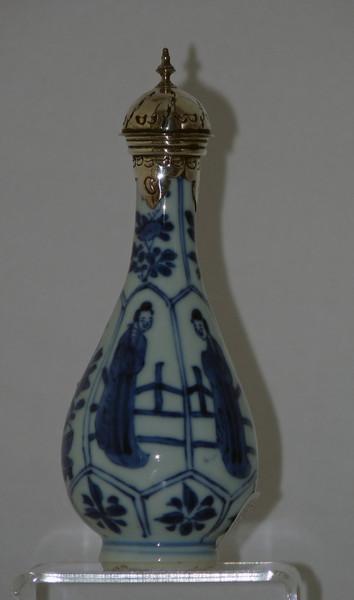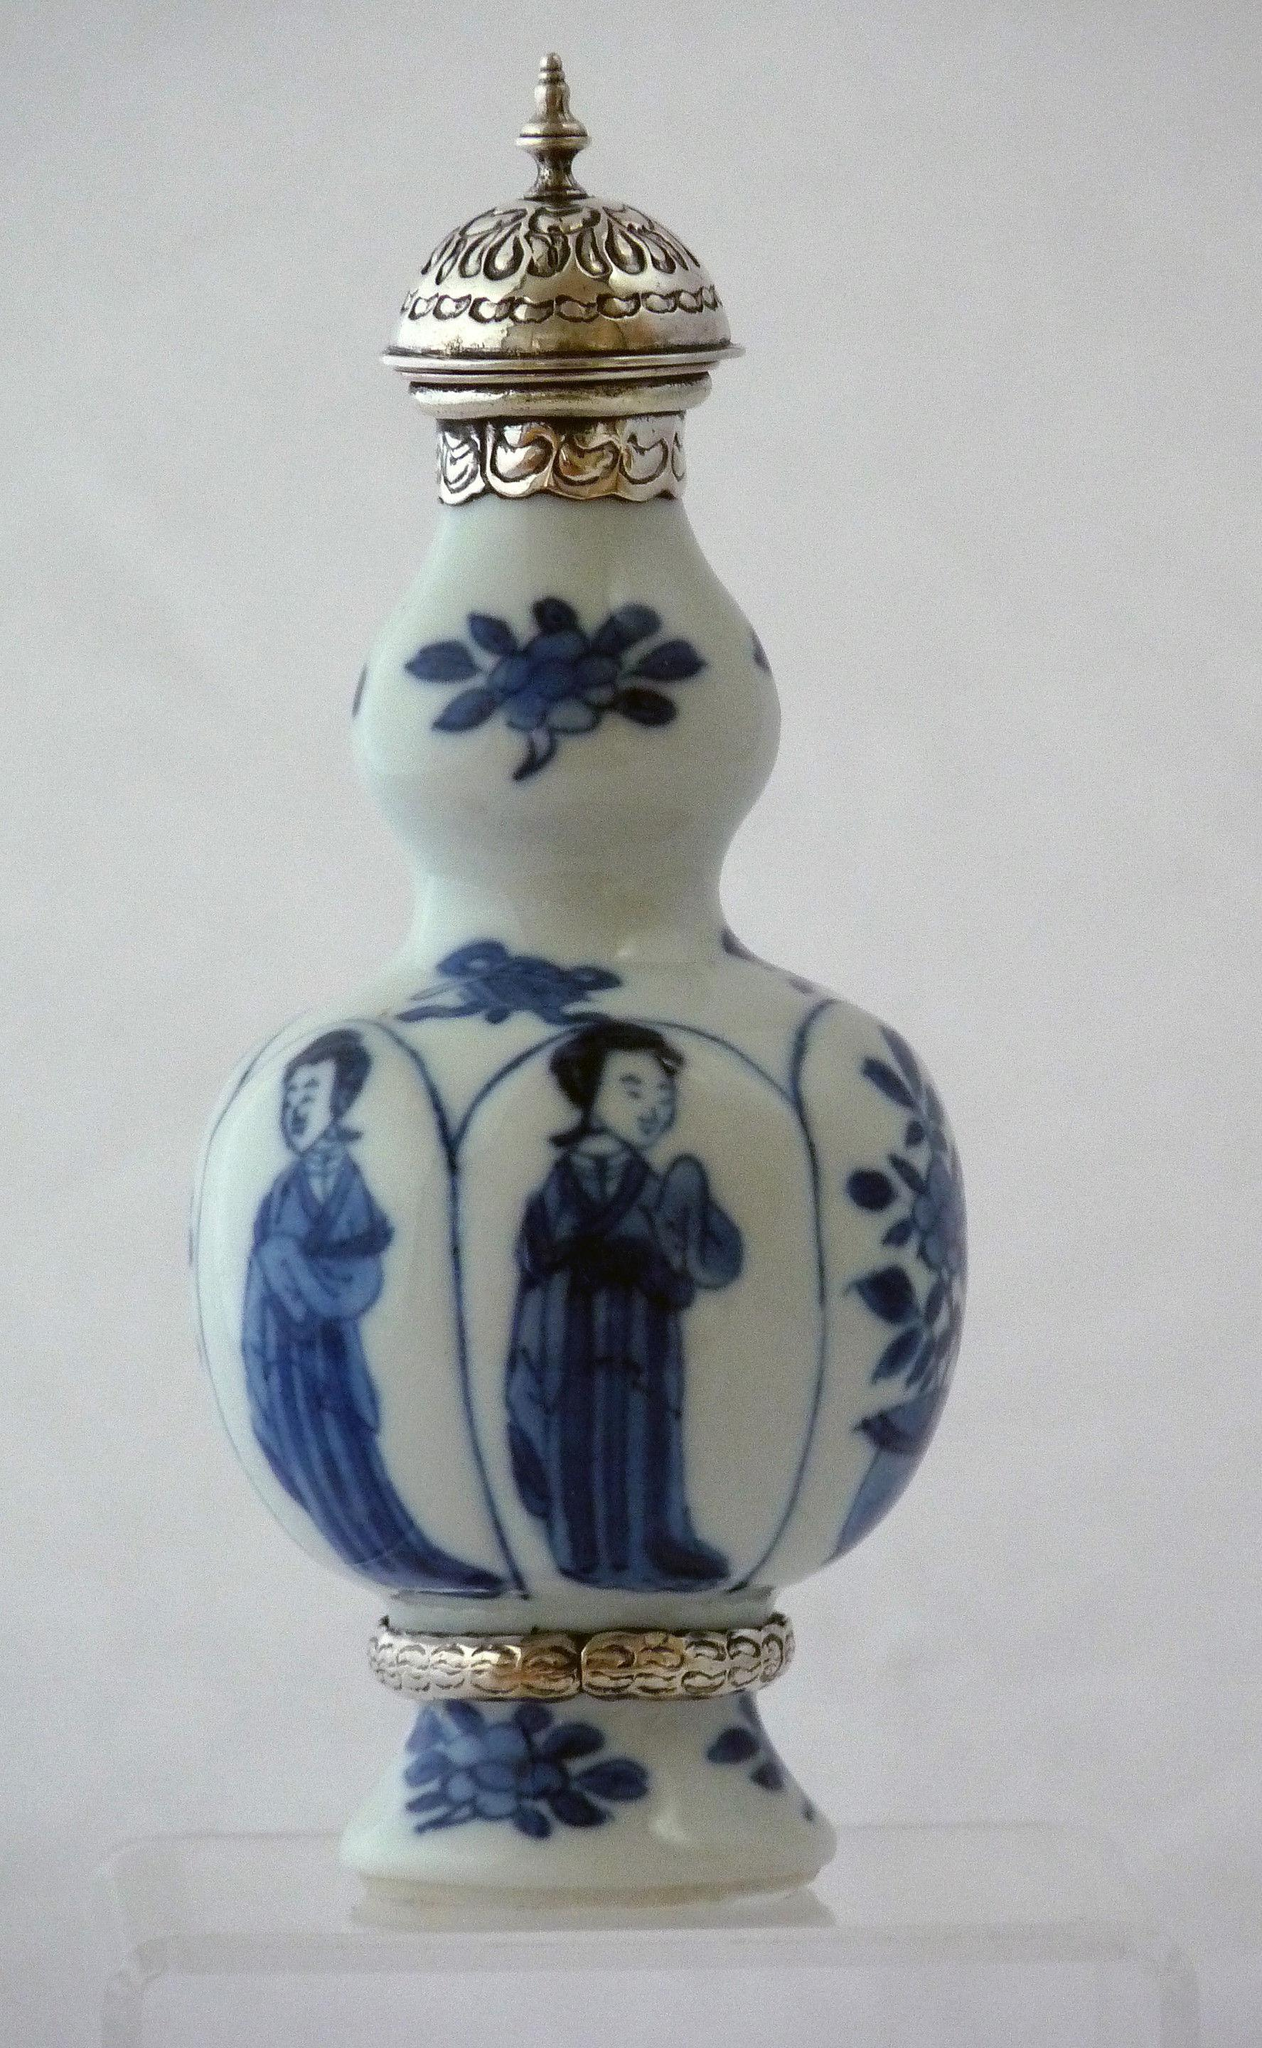The first image is the image on the left, the second image is the image on the right. For the images shown, is this caption "The vase in the image on the right has a bulb shaped neck." true? Answer yes or no. Yes. The first image is the image on the left, the second image is the image on the right. For the images shown, is this caption "Each image contains a single white vase with blue decoration, and no vase has a cover." true? Answer yes or no. No. 